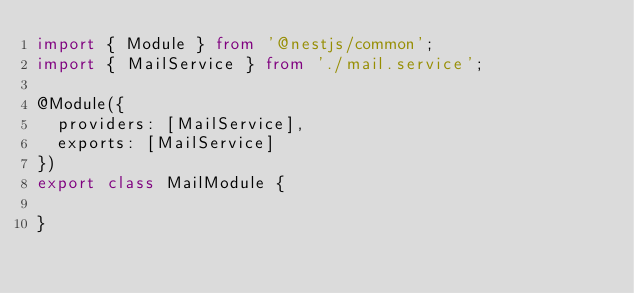<code> <loc_0><loc_0><loc_500><loc_500><_TypeScript_>import { Module } from '@nestjs/common';
import { MailService } from './mail.service';

@Module({
  providers: [MailService],
  exports: [MailService]
})
export class MailModule {

}

</code> 